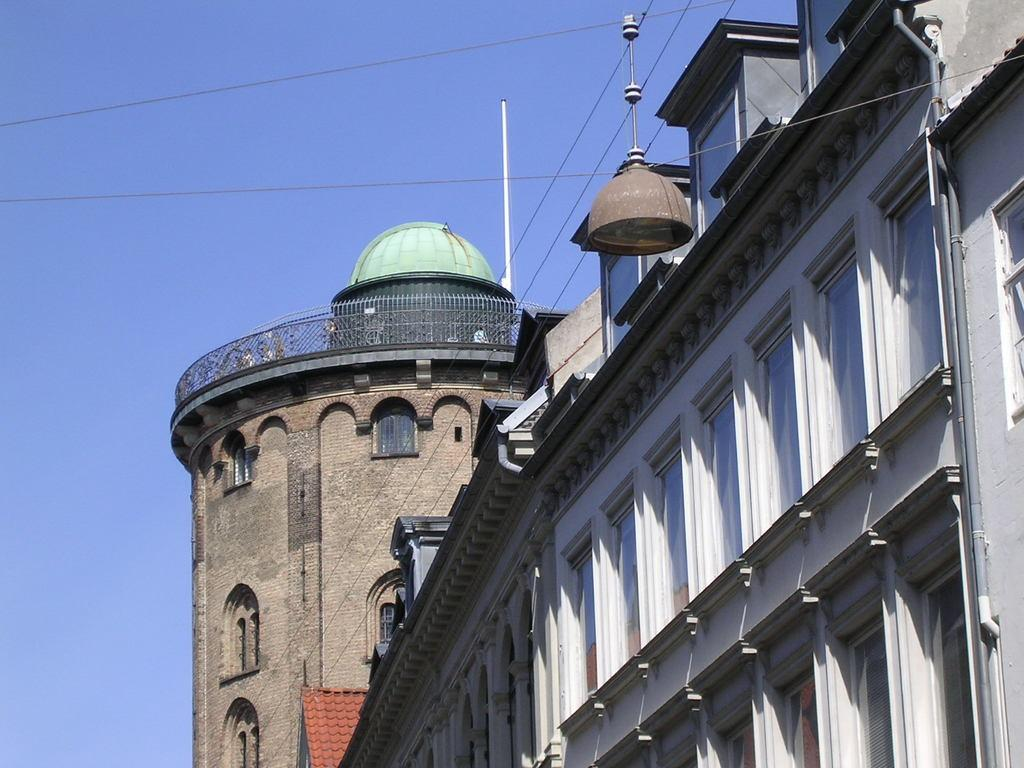What type of structure is present in the image? There is a building in the image. What feature can be seen on the building? The building has windows. What is located on top of the building? There is a railing on top of the building. What other objects are visible in the image? There are poles in the image. What can be seen in the background of the image? The sky is visible in the background of the image. Where is the playground located in the image? There is no playground present in the image. What type of credit can be seen on the building in the image? There is no credit visible on the building in the image. 